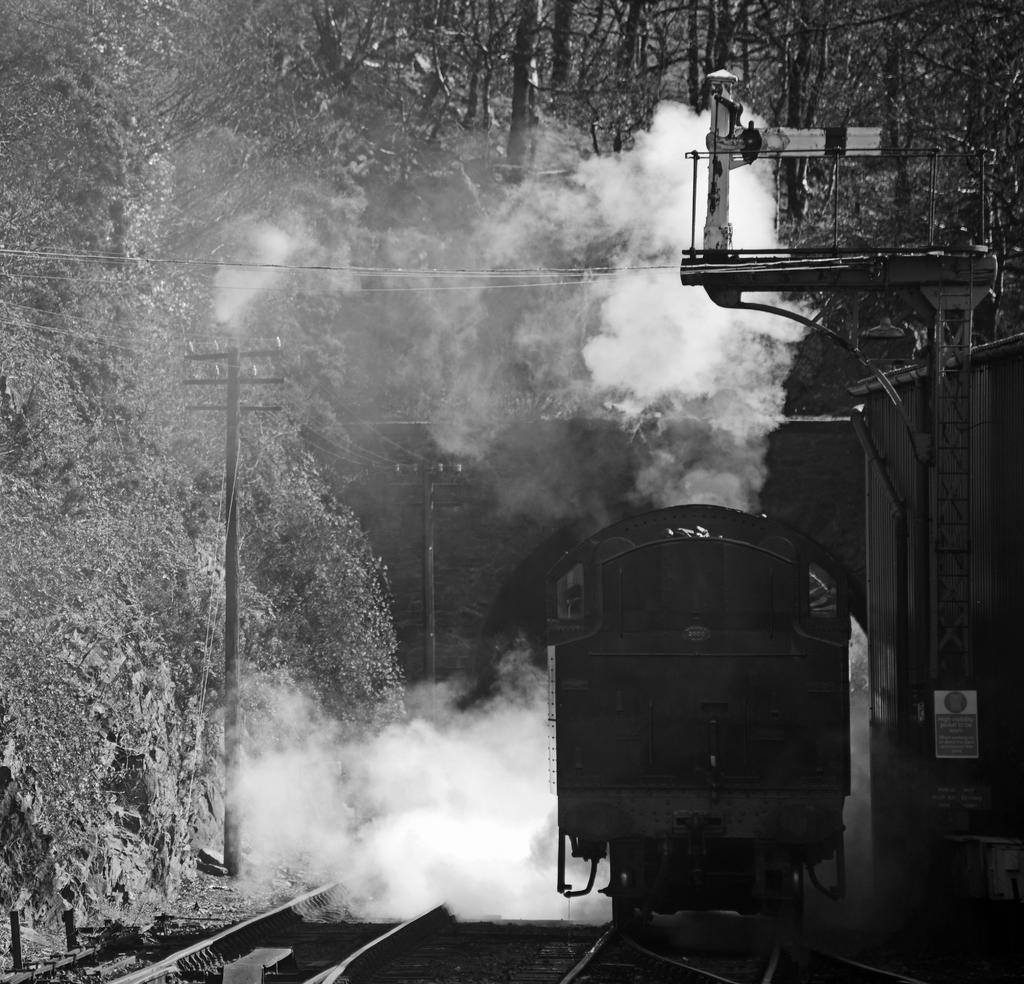In one or two sentences, can you explain what this image depicts? Here in this picture we can see a train present on a railway track and beside that also we can see other tracks present and we can see smoke released by the engine and we can see electric poles with wires hanging over there and we can also see plants and trees covered over there. 